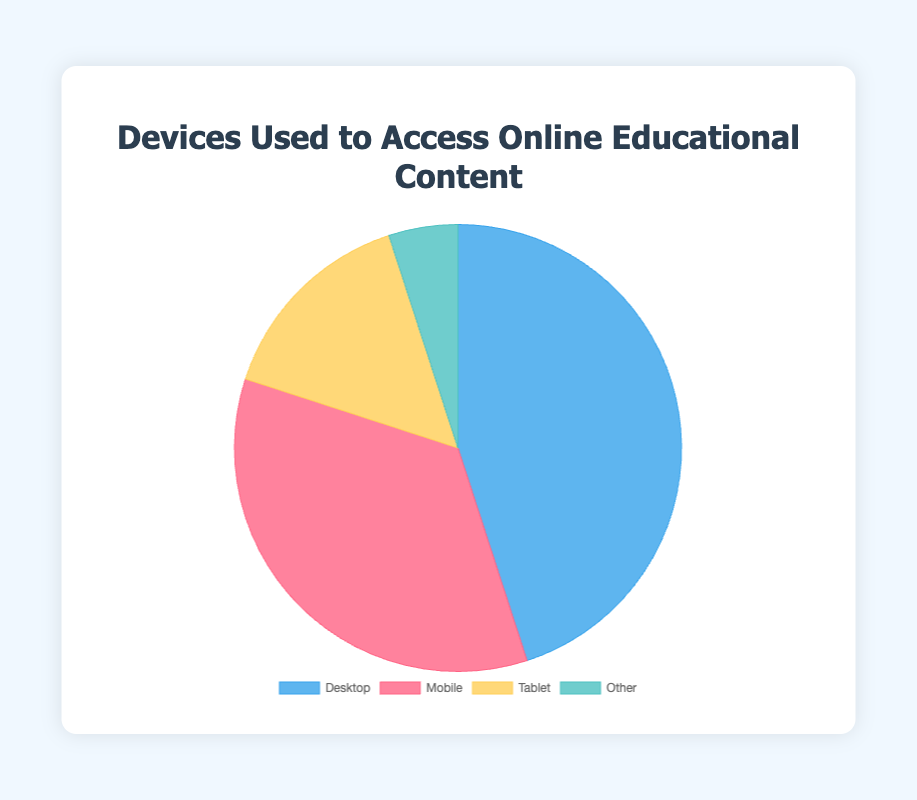Which device has the highest usage percentage? The figure shows the percentage usage of various devices. The Desktop has the highest percentage with 45%.
Answer: Desktop What is the total percentage of usage for Mobile and Tablet combined? Adding the usage percentages for Mobile (35%) and Tablet (15%) gives 35 + 15 = 50%.
Answer: 50% Which device has the lowest usage percentage? The figure indicates that 'Other' has the lowest percentage, which is 5%.
Answer: Other How much more is the usage percentage of Desktop compared to Tablet? Subtract the Tablet's usage percentage (15%) from the Desktop's (45%): 45 - 15 = 30%.
Answer: 30% What is the difference between the usage percentages of Mobile and Other? Subtract the percentage for Other (5%) from the percentage for Mobile (35%): 35 - 5 = 30%.
Answer: 30% Is the usage percentage of Mobile greater than Desktop? By comparing the usage percentages, Mobile (35%) is less than Desktop (45%).
Answer: No What color represents the Mobile device in the pie chart? Visually, the color representing Mobile in the pie chart is the reddish color.
Answer: Red What portion of the usage percentage does Tablet constitute out of the total 100%? The Tablet constitutes 15% of the total usage percentage of 100%.
Answer: 15% Are the combined usage percentages of Mobile and Tablet greater than Desktop? Combining Mobile (35%) and Tablet (15%) gives 50%, which is greater than Desktop's 45%.
Answer: Yes What is the average usage percentage of all devices? Sum all the usage percentages: 45 + 35 + 15 + 5 = 100%. Then, divide by the number of devices (4): 100 / 4 = 25%.
Answer: 25% 